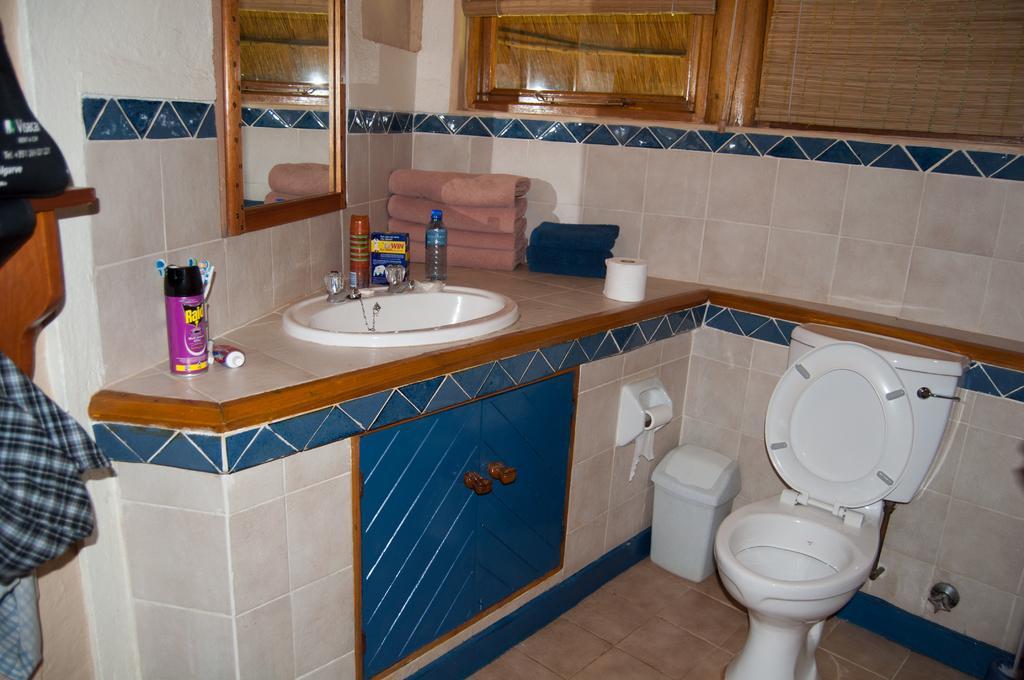Describe this image in one or two sentences. In this picture we can see a toilet seat, flush tank, dust bin, tissue paper rolls, cupboard, sink, tap, bottles, box, brushes, towel, mirror, curtain, clothes and the wall with tiles. 